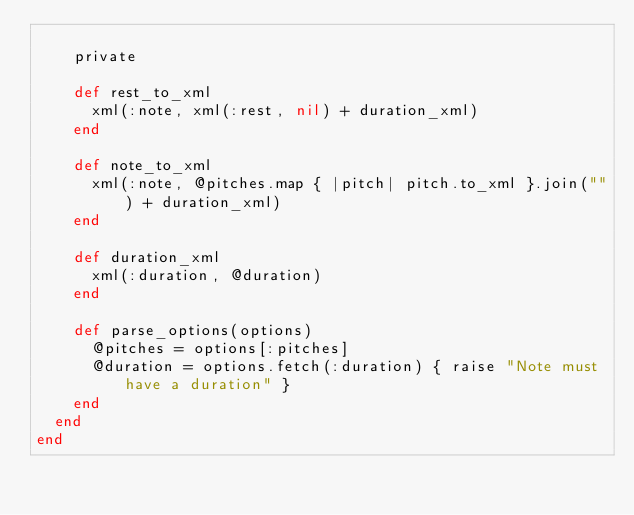Convert code to text. <code><loc_0><loc_0><loc_500><loc_500><_Ruby_>
    private

    def rest_to_xml
      xml(:note, xml(:rest, nil) + duration_xml)
    end

    def note_to_xml
      xml(:note, @pitches.map { |pitch| pitch.to_xml }.join("") + duration_xml)
    end

    def duration_xml
      xml(:duration, @duration)
    end

    def parse_options(options)
      @pitches = options[:pitches]
      @duration = options.fetch(:duration) { raise "Note must have a duration" }
    end
  end
end
</code> 